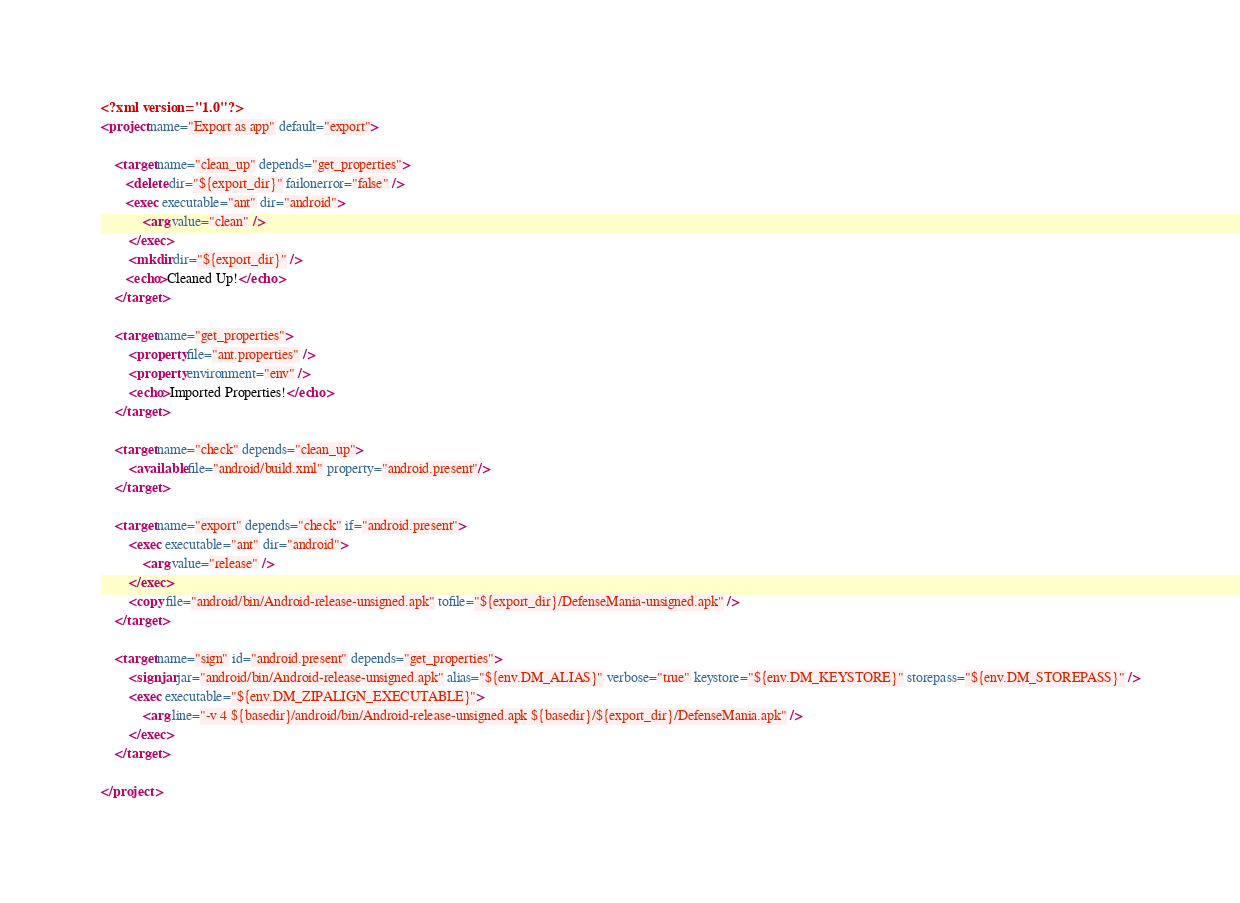Convert code to text. <code><loc_0><loc_0><loc_500><loc_500><_XML_><?xml version="1.0"?>
<project name="Export as app" default="export">

	<target name="clean_up" depends="get_properties">
	   <delete dir="${export_dir}" failonerror="false" />
	   <exec executable="ant" dir="android">
			<arg value="clean" />
		</exec>
		<mkdir dir="${export_dir}" />
	   <echo>Cleaned Up!</echo>
	</target>

	<target name="get_properties">
	    <property file="ant.properties" />
		<property environment="env" />
		<echo>Imported Properties!</echo>
	</target>

	<target name="check" depends="clean_up">
	    <available file="android/build.xml" property="android.present"/>
	</target>

	<target name="export" depends="check" if="android.present">
		<exec executable="ant" dir="android">
			<arg value="release" />
		</exec>
		<copy file="android/bin/Android-release-unsigned.apk" tofile="${export_dir}/DefenseMania-unsigned.apk" />
	</target>

	<target name="sign" id="android.present" depends="get_properties">
		<signjar jar="android/bin/Android-release-unsigned.apk" alias="${env.DM_ALIAS}" verbose="true" keystore="${env.DM_KEYSTORE}" storepass="${env.DM_STOREPASS}" />
		<exec executable="${env.DM_ZIPALIGN_EXECUTABLE}">
			<arg line="-v 4 ${basedir}/android/bin/Android-release-unsigned.apk ${basedir}/${export_dir}/DefenseMania.apk" />
		</exec>
	</target>

</project></code> 